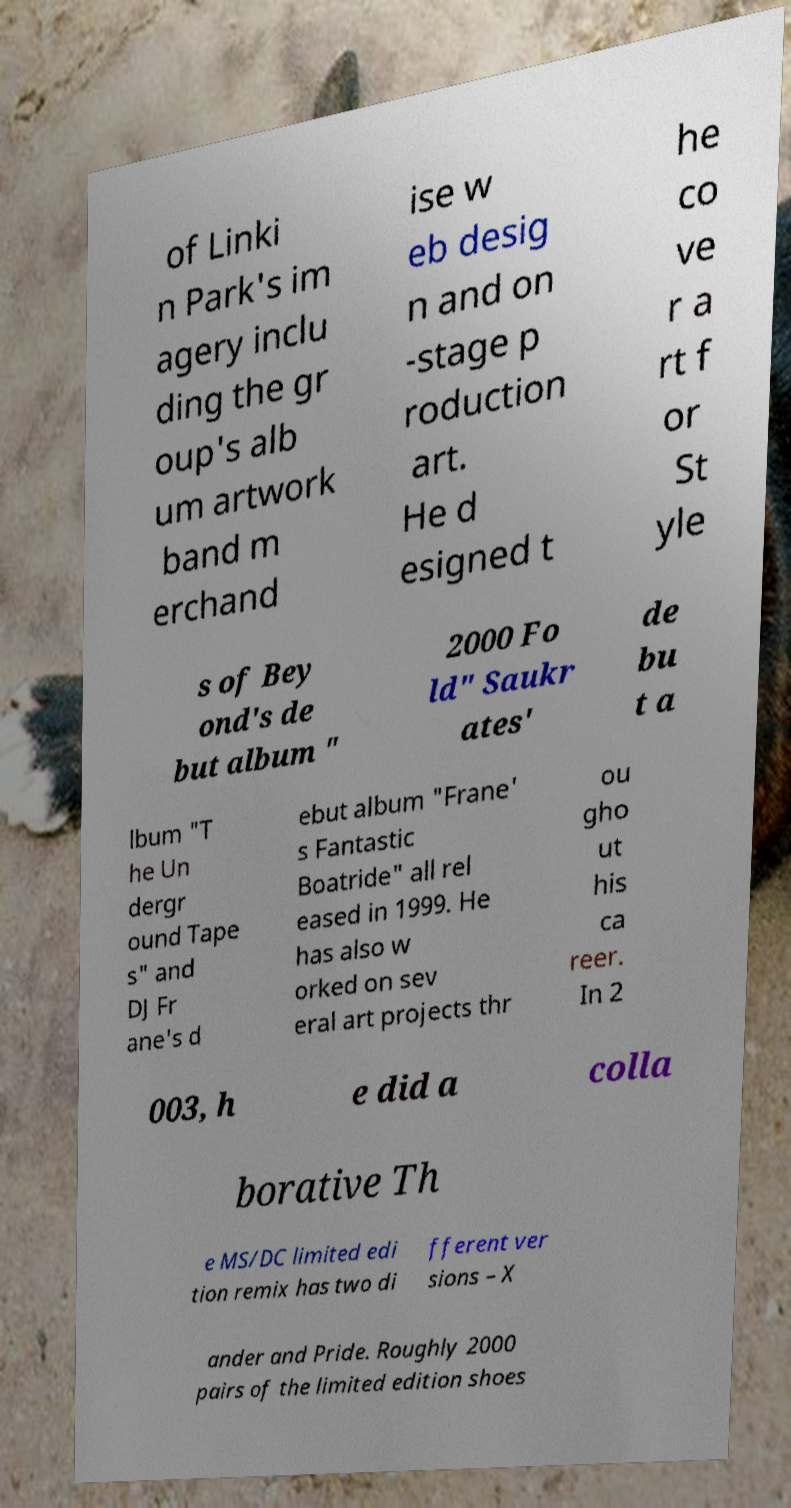Could you extract and type out the text from this image? of Linki n Park's im agery inclu ding the gr oup's alb um artwork band m erchand ise w eb desig n and on -stage p roduction art. He d esigned t he co ve r a rt f or St yle s of Bey ond's de but album " 2000 Fo ld" Saukr ates' de bu t a lbum "T he Un dergr ound Tape s" and DJ Fr ane's d ebut album "Frane' s Fantastic Boatride" all rel eased in 1999. He has also w orked on sev eral art projects thr ou gho ut his ca reer. In 2 003, h e did a colla borative Th e MS/DC limited edi tion remix has two di fferent ver sions – X ander and Pride. Roughly 2000 pairs of the limited edition shoes 